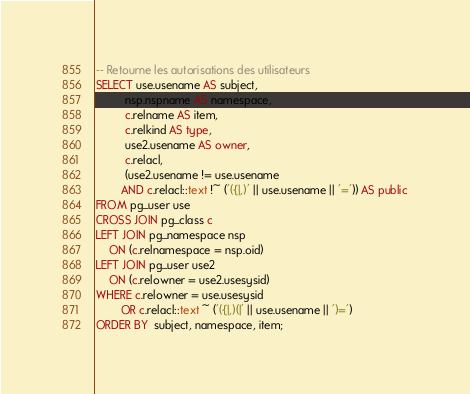Convert code to text. <code><loc_0><loc_0><loc_500><loc_500><_SQL_>-- Retourne les autorisations des utilisateurs
SELECT use.usename AS subject,
         nsp.nspname AS namespace,
         c.relname AS item,
         c.relkind AS type,
         use2.usename AS owner,
         c.relacl,
         (use2.usename != use.usename
        AND c.relacl::text !~ ('({|,)' || use.usename || '=')) AS public
FROM pg_user use
CROSS JOIN pg_class c
LEFT JOIN pg_namespace nsp
    ON (c.relnamespace = nsp.oid)
LEFT JOIN pg_user use2
    ON (c.relowner = use2.usesysid)
WHERE c.relowner = use.usesysid
        OR c.relacl::text ~ ('({|,)(|' || use.usename || ')=')
ORDER BY  subject, namespace, item;</code> 